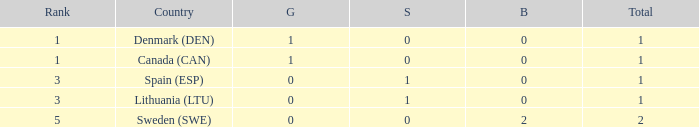I'm looking to parse the entire table for insights. Could you assist me with that? {'header': ['Rank', 'Country', 'G', 'S', 'B', 'Total'], 'rows': [['1', 'Denmark (DEN)', '1', '0', '0', '1'], ['1', 'Canada (CAN)', '1', '0', '0', '1'], ['3', 'Spain (ESP)', '0', '1', '0', '1'], ['3', 'Lithuania (LTU)', '0', '1', '0', '1'], ['5', 'Sweden (SWE)', '0', '0', '2', '2']]} What is the number of gold medals for Lithuania (ltu), when the total is more than 1? None. 